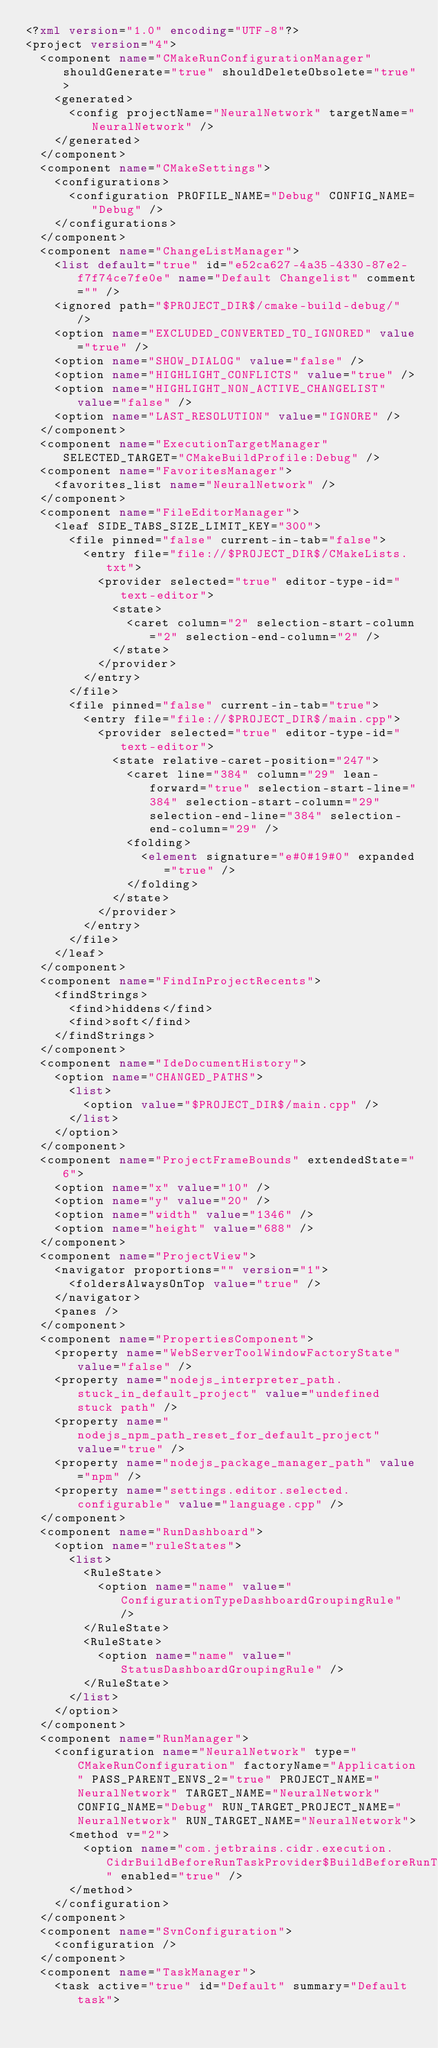<code> <loc_0><loc_0><loc_500><loc_500><_XML_><?xml version="1.0" encoding="UTF-8"?>
<project version="4">
  <component name="CMakeRunConfigurationManager" shouldGenerate="true" shouldDeleteObsolete="true">
    <generated>
      <config projectName="NeuralNetwork" targetName="NeuralNetwork" />
    </generated>
  </component>
  <component name="CMakeSettings">
    <configurations>
      <configuration PROFILE_NAME="Debug" CONFIG_NAME="Debug" />
    </configurations>
  </component>
  <component name="ChangeListManager">
    <list default="true" id="e52ca627-4a35-4330-87e2-f7f74ce7fe0e" name="Default Changelist" comment="" />
    <ignored path="$PROJECT_DIR$/cmake-build-debug/" />
    <option name="EXCLUDED_CONVERTED_TO_IGNORED" value="true" />
    <option name="SHOW_DIALOG" value="false" />
    <option name="HIGHLIGHT_CONFLICTS" value="true" />
    <option name="HIGHLIGHT_NON_ACTIVE_CHANGELIST" value="false" />
    <option name="LAST_RESOLUTION" value="IGNORE" />
  </component>
  <component name="ExecutionTargetManager" SELECTED_TARGET="CMakeBuildProfile:Debug" />
  <component name="FavoritesManager">
    <favorites_list name="NeuralNetwork" />
  </component>
  <component name="FileEditorManager">
    <leaf SIDE_TABS_SIZE_LIMIT_KEY="300">
      <file pinned="false" current-in-tab="false">
        <entry file="file://$PROJECT_DIR$/CMakeLists.txt">
          <provider selected="true" editor-type-id="text-editor">
            <state>
              <caret column="2" selection-start-column="2" selection-end-column="2" />
            </state>
          </provider>
        </entry>
      </file>
      <file pinned="false" current-in-tab="true">
        <entry file="file://$PROJECT_DIR$/main.cpp">
          <provider selected="true" editor-type-id="text-editor">
            <state relative-caret-position="247">
              <caret line="384" column="29" lean-forward="true" selection-start-line="384" selection-start-column="29" selection-end-line="384" selection-end-column="29" />
              <folding>
                <element signature="e#0#19#0" expanded="true" />
              </folding>
            </state>
          </provider>
        </entry>
      </file>
    </leaf>
  </component>
  <component name="FindInProjectRecents">
    <findStrings>
      <find>hiddens</find>
      <find>soft</find>
    </findStrings>
  </component>
  <component name="IdeDocumentHistory">
    <option name="CHANGED_PATHS">
      <list>
        <option value="$PROJECT_DIR$/main.cpp" />
      </list>
    </option>
  </component>
  <component name="ProjectFrameBounds" extendedState="6">
    <option name="x" value="10" />
    <option name="y" value="20" />
    <option name="width" value="1346" />
    <option name="height" value="688" />
  </component>
  <component name="ProjectView">
    <navigator proportions="" version="1">
      <foldersAlwaysOnTop value="true" />
    </navigator>
    <panes />
  </component>
  <component name="PropertiesComponent">
    <property name="WebServerToolWindowFactoryState" value="false" />
    <property name="nodejs_interpreter_path.stuck_in_default_project" value="undefined stuck path" />
    <property name="nodejs_npm_path_reset_for_default_project" value="true" />
    <property name="nodejs_package_manager_path" value="npm" />
    <property name="settings.editor.selected.configurable" value="language.cpp" />
  </component>
  <component name="RunDashboard">
    <option name="ruleStates">
      <list>
        <RuleState>
          <option name="name" value="ConfigurationTypeDashboardGroupingRule" />
        </RuleState>
        <RuleState>
          <option name="name" value="StatusDashboardGroupingRule" />
        </RuleState>
      </list>
    </option>
  </component>
  <component name="RunManager">
    <configuration name="NeuralNetwork" type="CMakeRunConfiguration" factoryName="Application" PASS_PARENT_ENVS_2="true" PROJECT_NAME="NeuralNetwork" TARGET_NAME="NeuralNetwork" CONFIG_NAME="Debug" RUN_TARGET_PROJECT_NAME="NeuralNetwork" RUN_TARGET_NAME="NeuralNetwork">
      <method v="2">
        <option name="com.jetbrains.cidr.execution.CidrBuildBeforeRunTaskProvider$BuildBeforeRunTask" enabled="true" />
      </method>
    </configuration>
  </component>
  <component name="SvnConfiguration">
    <configuration />
  </component>
  <component name="TaskManager">
    <task active="true" id="Default" summary="Default task"></code> 